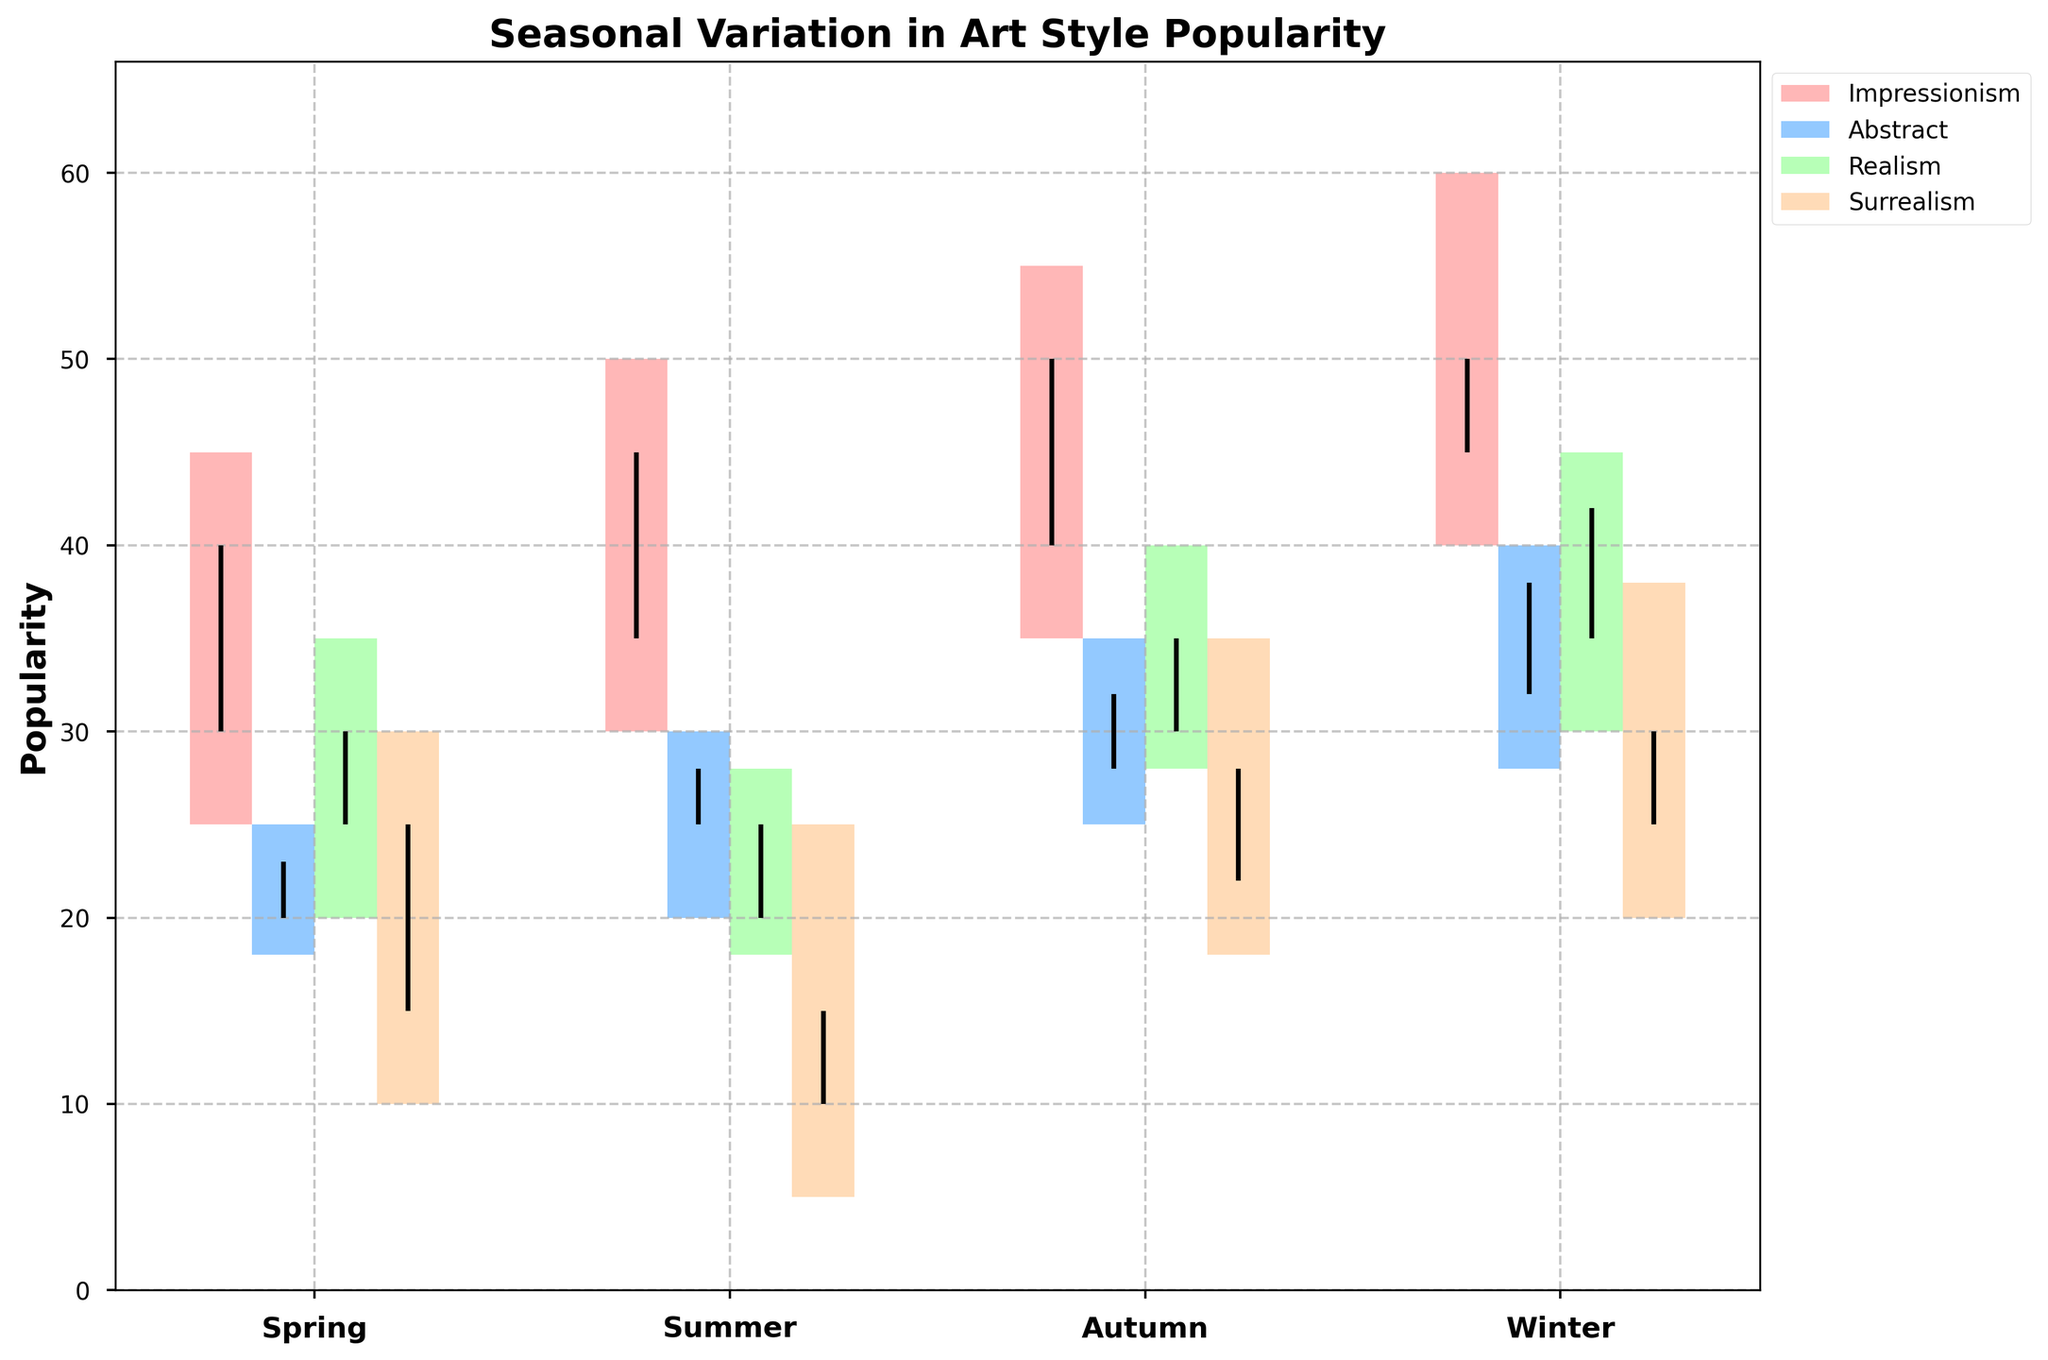What's the title of the figure? The title of the figure appears at the top and describes the overall theme of the visualization. In this plot, the title is "Seasonal Variation in Art Style Popularity."
Answer: Seasonal Variation in Art Style Popularity Which season shows the highest popularity for Impressionism? Impressionism's highest popularity is shown by the top of the candlestick for each season's bar. In winter, Impressionism reaches a high of 60, the highest among all seasons.
Answer: Winter What is the average low popularity of Abstract art over all seasons? To find the average, sum the low popularity values for Abstract in all seasons and divide by the number of seasons. (Spring 18 + Summer 20 + Autumn 25 + Winter 28) / 4 = 22.75.
Answer: 22.75 How does the popularity of Realism in Summer compare to that in Spring? By examining the lengths of the candlesticks and the high values, in Summer, Realism ranges from 18 to 28, while in Spring it ranges from 20 to 35. Realism in Spring has a broader range and higher peak.
Answer: Spring has broader range and higher peak Which art style shows the smallest variation in popularity in Spring? Variation is determined by the height of the candlestick. Surrealism has the smallest candlestick height (30 - 10 = 20) in Spring, indicating the smallest variation in popularity.
Answer: Surrealism In which season does Surrealism's closing popularity exceed its opening popularity? The closing value exceeds the opening value if the top end of the vertical line (close) is higher than the bottom end (open). In seasons Spring, Summer, and Autumn, the close exceeds the open for Surrealism.
Answer: Spring, Summer, Autumn How does the popularity of Abstract in Autumn compare to that in Winter? Consider the high values. Abstract's high value in Autumn is 35, while in Winter it is 40. This indicates that Abstract is more popular in Winter compared to Autumn when examining high values.
Answer: More popular in Winter What is the highest closing popularity across all art styles and seasons, and which style and season does it belong to? Identify the highest closing value among all vertical line tops for each art style and season. The highest closing value is 50, belonging to Impressionism in Winter.
Answer: Impressionism, Winter Which art style shows increased popularity every season for its closing values? Look at the closing values for each season across the art styles. Impressionism's closing values increase consistently: Spring 40, Summer 45, Autumn 50, and Winter 50.
Answer: Impressionism In which season does Abstract have its lowest opening value? The opening value for Abstract in each season is noted, and the smallest is identified. The lowest opening value for Abstract is 20 in Spring.
Answer: Spring 